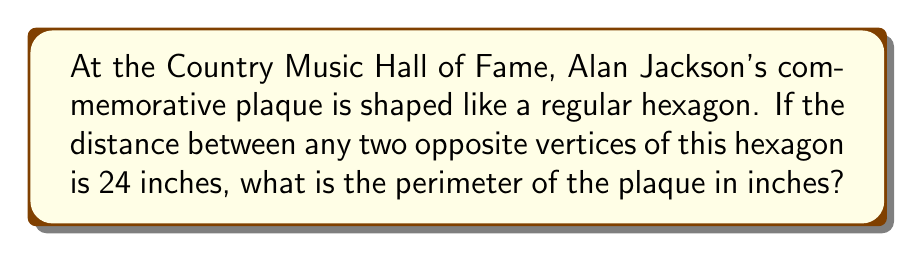Could you help me with this problem? Let's approach this step-by-step:

1) In a regular hexagon, the distance between opposite vertices is equal to twice the length of one side. Let's call the side length $s$.

   $2s = 24$ inches

2) Solving for $s$:
   
   $s = 12$ inches

3) Now, we need to calculate the perimeter. The perimeter of a regular hexagon is the sum of all six sides. Since each side is 12 inches:

   Perimeter $= 6s = 6 \cdot 12 = 72$ inches

[asy]
import geometry;

size(200);
real s = 5;
pair A = (s*sqrt(3),s);
pair B = (s*sqrt(3),-s);
pair C = (0,-2s);
pair D = (-s*sqrt(3),-s);
pair E = (-s*sqrt(3),s);
pair F = (0,2s);

draw(A--B--C--D--E--F--cycle);
draw(A--D);
draw(B--E);
draw(C--F);

label("24\"", (A+D)/2, E);
label("12\"", (A+B)/2, E);
[/asy]

4) Therefore, the perimeter of Alan Jackson's commemorative plaque is 72 inches.
Answer: $72$ inches 